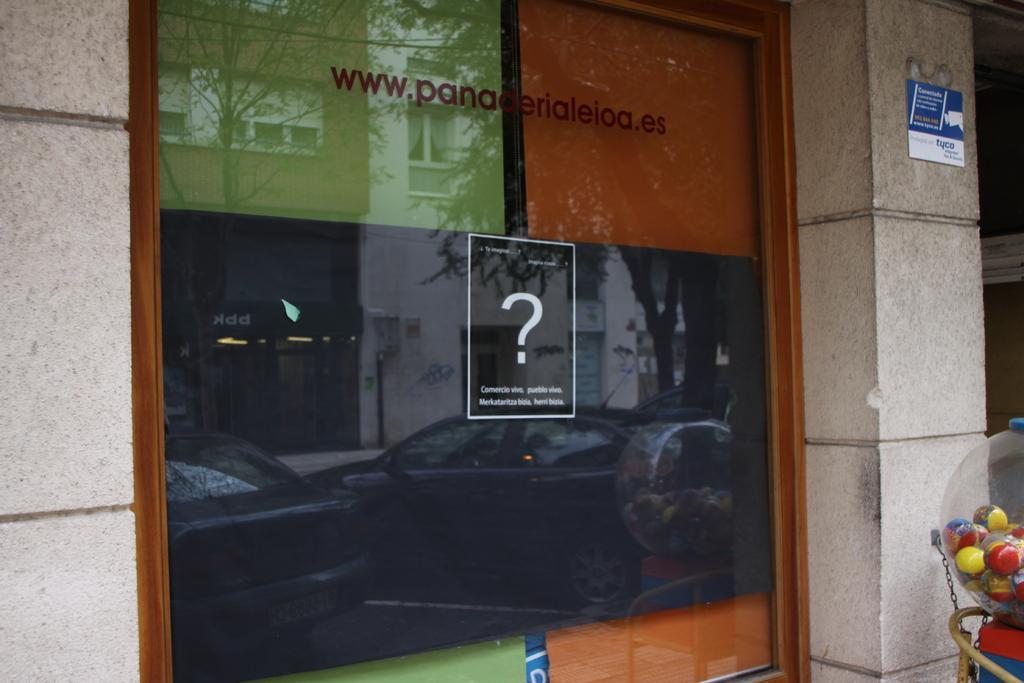Please provide a concise description of this image. This is the picture of a building. In this image there are reflections of buildings, trees and vehicles on the mirror and there are objects behind the mirror. On the right side of the image there is an object. There is a poster on the wall. There is a text on the mirror. 